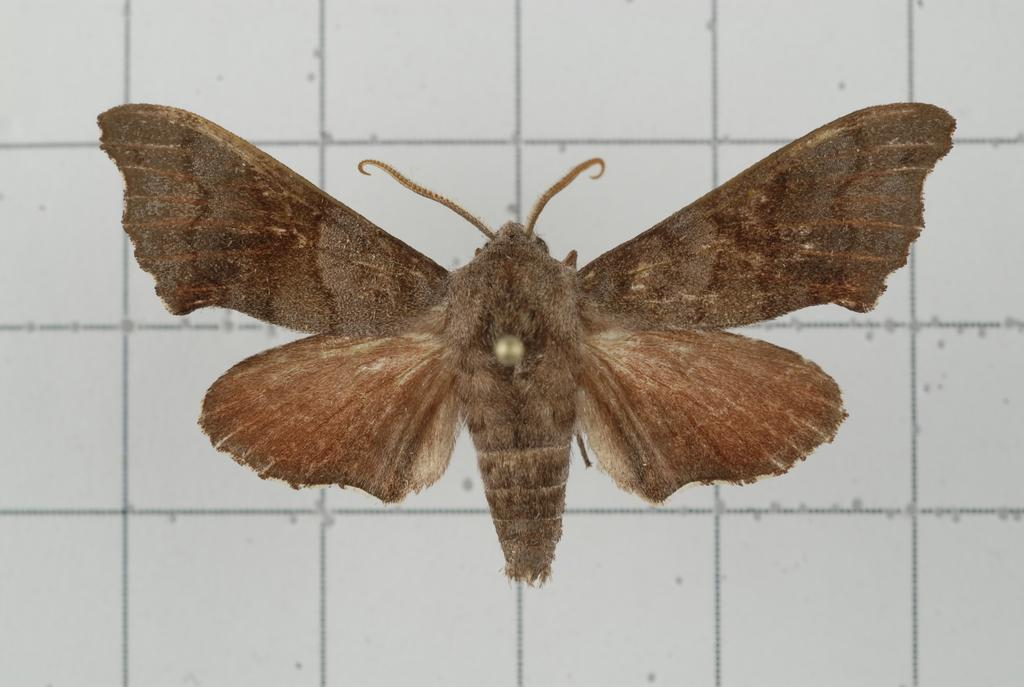What type of creature is present in the image? There is a butterfly in the image. Where is the butterfly located in the image? The butterfly is on the floor. What type of books are being discussed in the meeting in the image? There is no meeting or books present in the image; it only features a butterfly on the floor. What is the coil used for in the image? There is no coil present in the image; it only features a butterfly on the floor. 